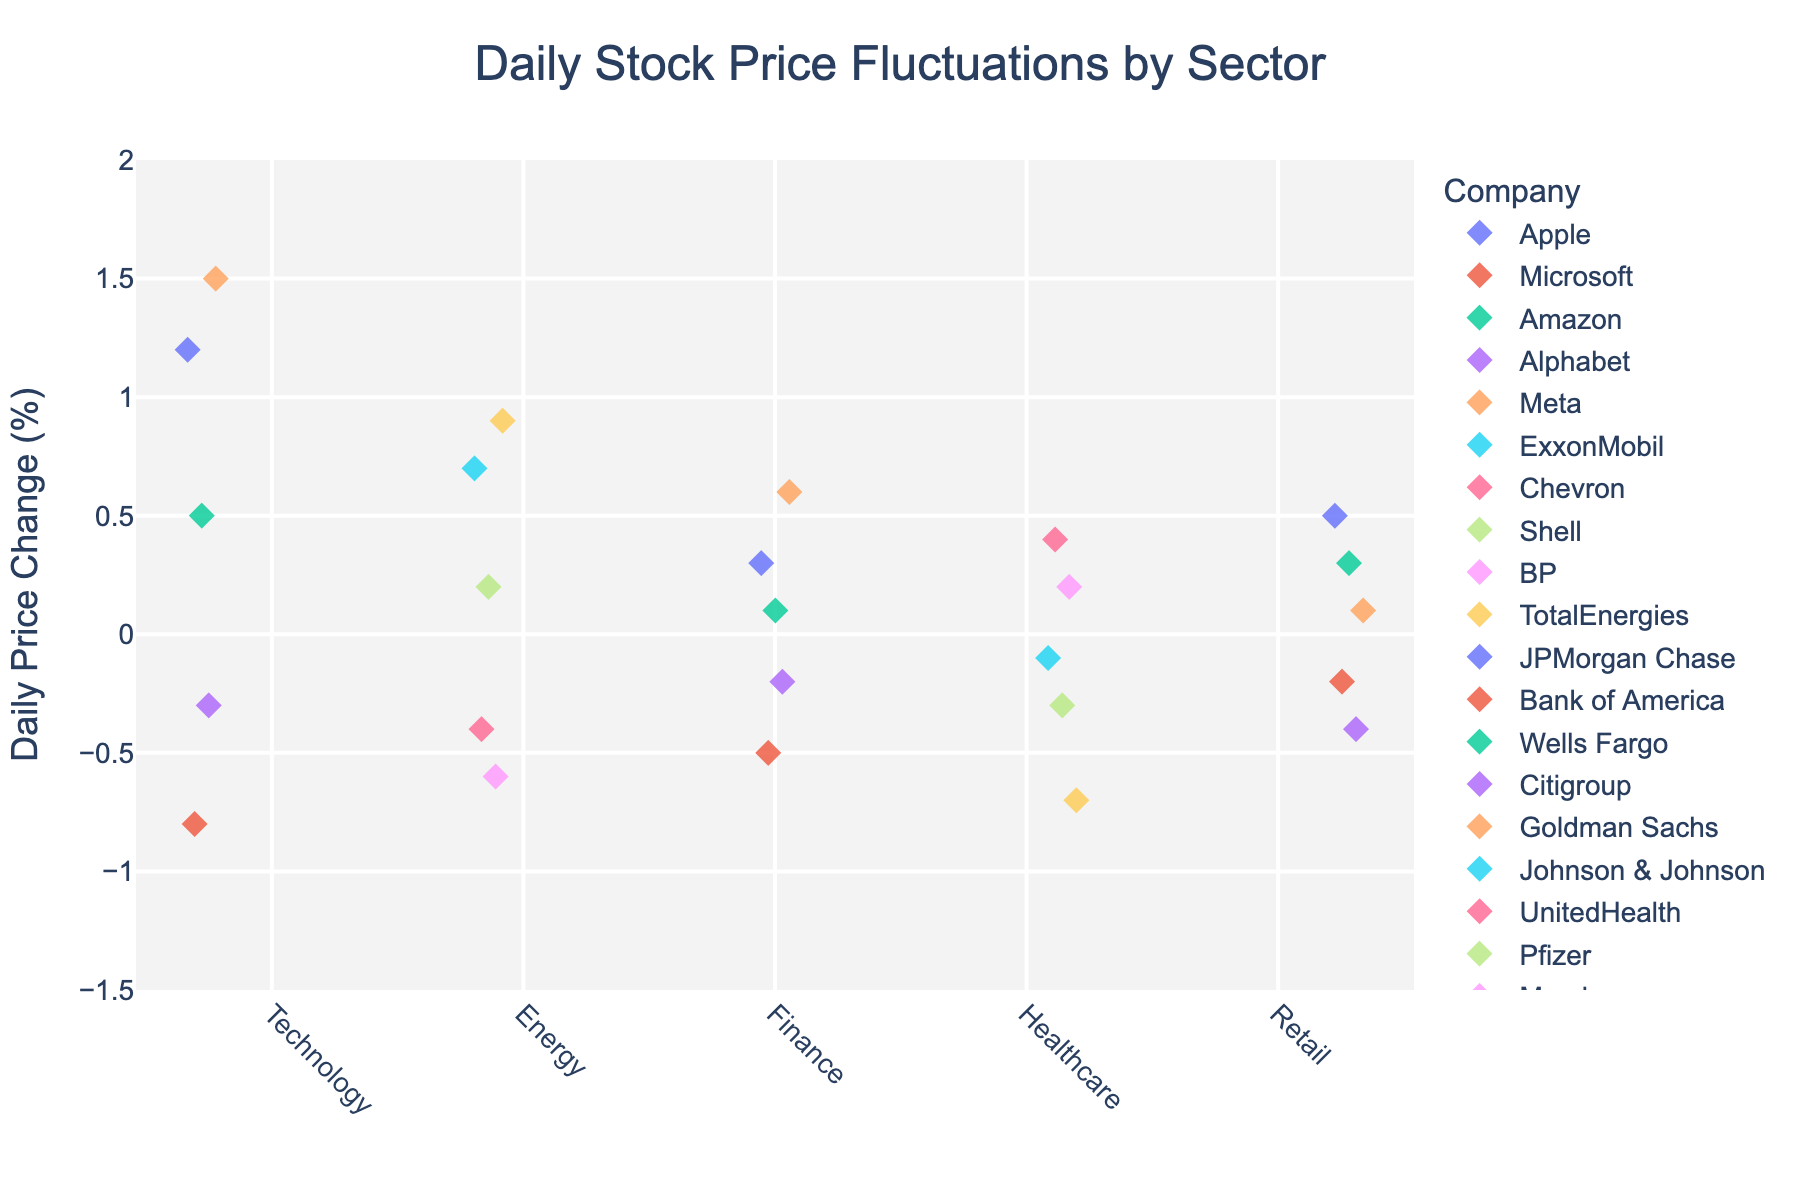What is the title of the strip plot? The title is displayed at the top of the plot and gives an overview of what the figure represents.
Answer: Daily Stock Price Fluctuations by Sector How many sectors are represented in the plot? Count the unique labels along the x-axis.
Answer: 5 Which company in the Technology sector had the highest daily price change? Look at the 'Technology' points and identify the one with the highest value on the y-axis.
Answer: Meta What is the range of the y-axis? Observe the range of values from the bottom to the top of the y-axis.
Answer: -1.5 to 2 Which sector shows the least fluctuation in daily stock prices? Compare the spread of points in each sector; the sector with points closest to each other has the least fluctuation.
Answer: Healthcare What is the average daily price change for companies in the Finance sector? Add the daily price changes for Finance companies and divide by the number of companies in that sector: (0.3 + -0.5 + 0.1 + -0.2 + 0.6) / 5 = 0.06
Answer: 0.06 Are there any sectors with only positive or only negative daily price changes? Identify if any sector’s points are all above or below zero on the y-axis.
Answer: No Which company has the most extreme negative change (largest negative value) in daily stock price? Look for the company with the lowest point on the y-axis.
Answer: AbbVie How does the daily price change of ExxonMobil compare to Chevron? Observe the y-axis values for ExxonMobil and Chevron in the Energy sector and compare.
Answer: ExxonMobil (0.7) is higher than Chevron (-0.4) What symbols are used to represent data points in the plot? Identify the shape of the markers used for each point in the plot.
Answer: Diamond 